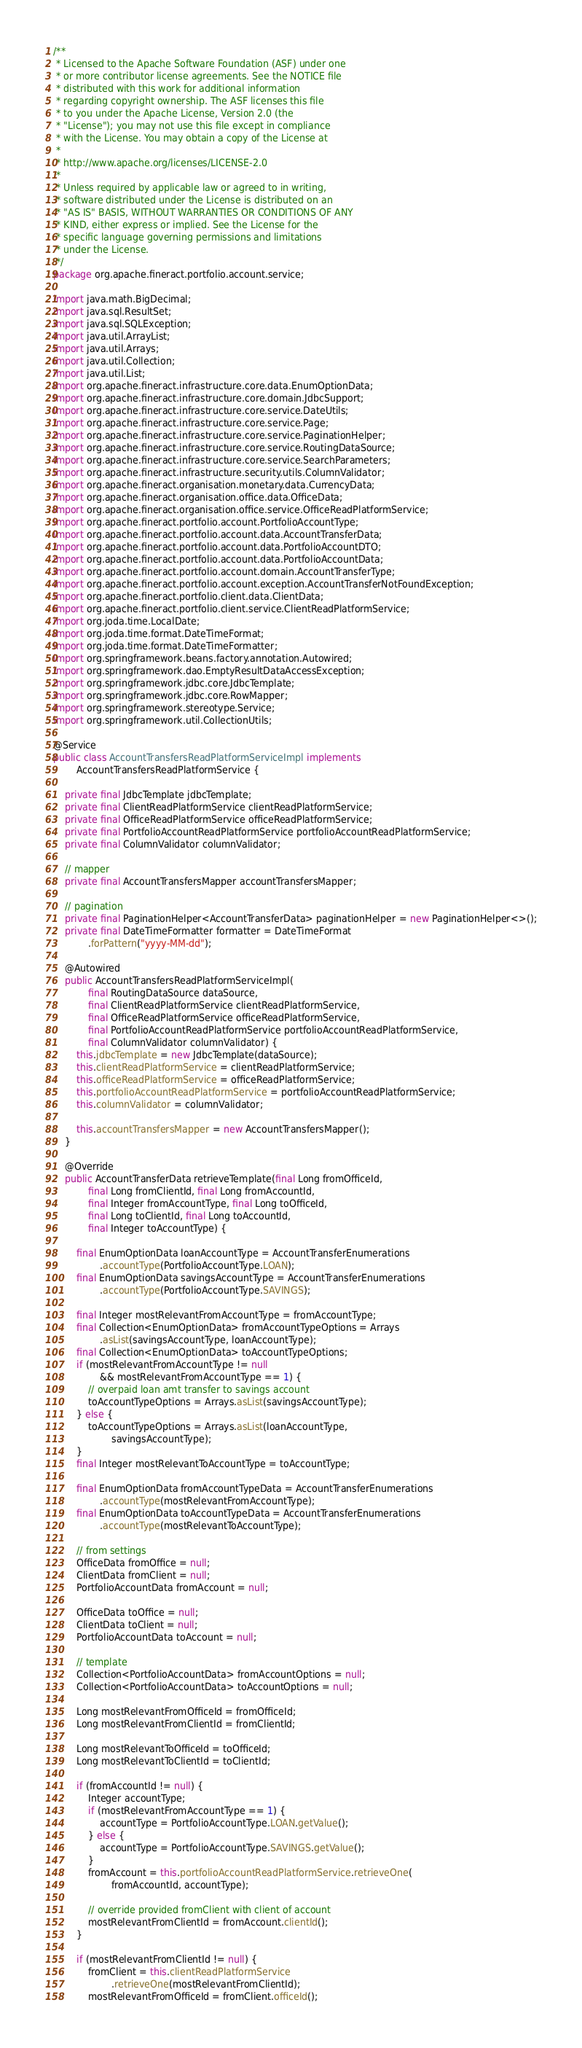Convert code to text. <code><loc_0><loc_0><loc_500><loc_500><_Java_>/**
 * Licensed to the Apache Software Foundation (ASF) under one
 * or more contributor license agreements. See the NOTICE file
 * distributed with this work for additional information
 * regarding copyright ownership. The ASF licenses this file
 * to you under the Apache License, Version 2.0 (the
 * "License"); you may not use this file except in compliance
 * with the License. You may obtain a copy of the License at
 *
 * http://www.apache.org/licenses/LICENSE-2.0
 *
 * Unless required by applicable law or agreed to in writing,
 * software distributed under the License is distributed on an
 * "AS IS" BASIS, WITHOUT WARRANTIES OR CONDITIONS OF ANY
 * KIND, either express or implied. See the License for the
 * specific language governing permissions and limitations
 * under the License.
 */
package org.apache.fineract.portfolio.account.service;

import java.math.BigDecimal;
import java.sql.ResultSet;
import java.sql.SQLException;
import java.util.ArrayList;
import java.util.Arrays;
import java.util.Collection;
import java.util.List;
import org.apache.fineract.infrastructure.core.data.EnumOptionData;
import org.apache.fineract.infrastructure.core.domain.JdbcSupport;
import org.apache.fineract.infrastructure.core.service.DateUtils;
import org.apache.fineract.infrastructure.core.service.Page;
import org.apache.fineract.infrastructure.core.service.PaginationHelper;
import org.apache.fineract.infrastructure.core.service.RoutingDataSource;
import org.apache.fineract.infrastructure.core.service.SearchParameters;
import org.apache.fineract.infrastructure.security.utils.ColumnValidator;
import org.apache.fineract.organisation.monetary.data.CurrencyData;
import org.apache.fineract.organisation.office.data.OfficeData;
import org.apache.fineract.organisation.office.service.OfficeReadPlatformService;
import org.apache.fineract.portfolio.account.PortfolioAccountType;
import org.apache.fineract.portfolio.account.data.AccountTransferData;
import org.apache.fineract.portfolio.account.data.PortfolioAccountDTO;
import org.apache.fineract.portfolio.account.data.PortfolioAccountData;
import org.apache.fineract.portfolio.account.domain.AccountTransferType;
import org.apache.fineract.portfolio.account.exception.AccountTransferNotFoundException;
import org.apache.fineract.portfolio.client.data.ClientData;
import org.apache.fineract.portfolio.client.service.ClientReadPlatformService;
import org.joda.time.LocalDate;
import org.joda.time.format.DateTimeFormat;
import org.joda.time.format.DateTimeFormatter;
import org.springframework.beans.factory.annotation.Autowired;
import org.springframework.dao.EmptyResultDataAccessException;
import org.springframework.jdbc.core.JdbcTemplate;
import org.springframework.jdbc.core.RowMapper;
import org.springframework.stereotype.Service;
import org.springframework.util.CollectionUtils;

@Service
public class AccountTransfersReadPlatformServiceImpl implements
        AccountTransfersReadPlatformService {

    private final JdbcTemplate jdbcTemplate;
    private final ClientReadPlatformService clientReadPlatformService;
    private final OfficeReadPlatformService officeReadPlatformService;
    private final PortfolioAccountReadPlatformService portfolioAccountReadPlatformService;
    private final ColumnValidator columnValidator;

    // mapper
    private final AccountTransfersMapper accountTransfersMapper;

    // pagination
    private final PaginationHelper<AccountTransferData> paginationHelper = new PaginationHelper<>();
    private final DateTimeFormatter formatter = DateTimeFormat
            .forPattern("yyyy-MM-dd");

    @Autowired
    public AccountTransfersReadPlatformServiceImpl(
            final RoutingDataSource dataSource,
            final ClientReadPlatformService clientReadPlatformService,
            final OfficeReadPlatformService officeReadPlatformService,
            final PortfolioAccountReadPlatformService portfolioAccountReadPlatformService,
            final ColumnValidator columnValidator) {
        this.jdbcTemplate = new JdbcTemplate(dataSource);
        this.clientReadPlatformService = clientReadPlatformService;
        this.officeReadPlatformService = officeReadPlatformService;
        this.portfolioAccountReadPlatformService = portfolioAccountReadPlatformService;
        this.columnValidator = columnValidator;

        this.accountTransfersMapper = new AccountTransfersMapper();
    }

    @Override
    public AccountTransferData retrieveTemplate(final Long fromOfficeId,
            final Long fromClientId, final Long fromAccountId,
            final Integer fromAccountType, final Long toOfficeId,
            final Long toClientId, final Long toAccountId,
            final Integer toAccountType) {

        final EnumOptionData loanAccountType = AccountTransferEnumerations
                .accountType(PortfolioAccountType.LOAN);
        final EnumOptionData savingsAccountType = AccountTransferEnumerations
                .accountType(PortfolioAccountType.SAVINGS);

        final Integer mostRelevantFromAccountType = fromAccountType;
        final Collection<EnumOptionData> fromAccountTypeOptions = Arrays
                .asList(savingsAccountType, loanAccountType);
        final Collection<EnumOptionData> toAccountTypeOptions;
        if (mostRelevantFromAccountType != null
                && mostRelevantFromAccountType == 1) {
            // overpaid loan amt transfer to savings account
            toAccountTypeOptions = Arrays.asList(savingsAccountType);
        } else {
            toAccountTypeOptions = Arrays.asList(loanAccountType,
                    savingsAccountType);
        }
        final Integer mostRelevantToAccountType = toAccountType;

        final EnumOptionData fromAccountTypeData = AccountTransferEnumerations
                .accountType(mostRelevantFromAccountType);
        final EnumOptionData toAccountTypeData = AccountTransferEnumerations
                .accountType(mostRelevantToAccountType);

        // from settings
        OfficeData fromOffice = null;
        ClientData fromClient = null;
        PortfolioAccountData fromAccount = null;

        OfficeData toOffice = null;
        ClientData toClient = null;
        PortfolioAccountData toAccount = null;

        // template
        Collection<PortfolioAccountData> fromAccountOptions = null;
        Collection<PortfolioAccountData> toAccountOptions = null;

        Long mostRelevantFromOfficeId = fromOfficeId;
        Long mostRelevantFromClientId = fromClientId;

        Long mostRelevantToOfficeId = toOfficeId;
        Long mostRelevantToClientId = toClientId;

        if (fromAccountId != null) {
            Integer accountType;
            if (mostRelevantFromAccountType == 1) {
                accountType = PortfolioAccountType.LOAN.getValue();
            } else {
                accountType = PortfolioAccountType.SAVINGS.getValue();
            }
            fromAccount = this.portfolioAccountReadPlatformService.retrieveOne(
                    fromAccountId, accountType);

            // override provided fromClient with client of account
            mostRelevantFromClientId = fromAccount.clientId();
        }

        if (mostRelevantFromClientId != null) {
            fromClient = this.clientReadPlatformService
                    .retrieveOne(mostRelevantFromClientId);
            mostRelevantFromOfficeId = fromClient.officeId();</code> 